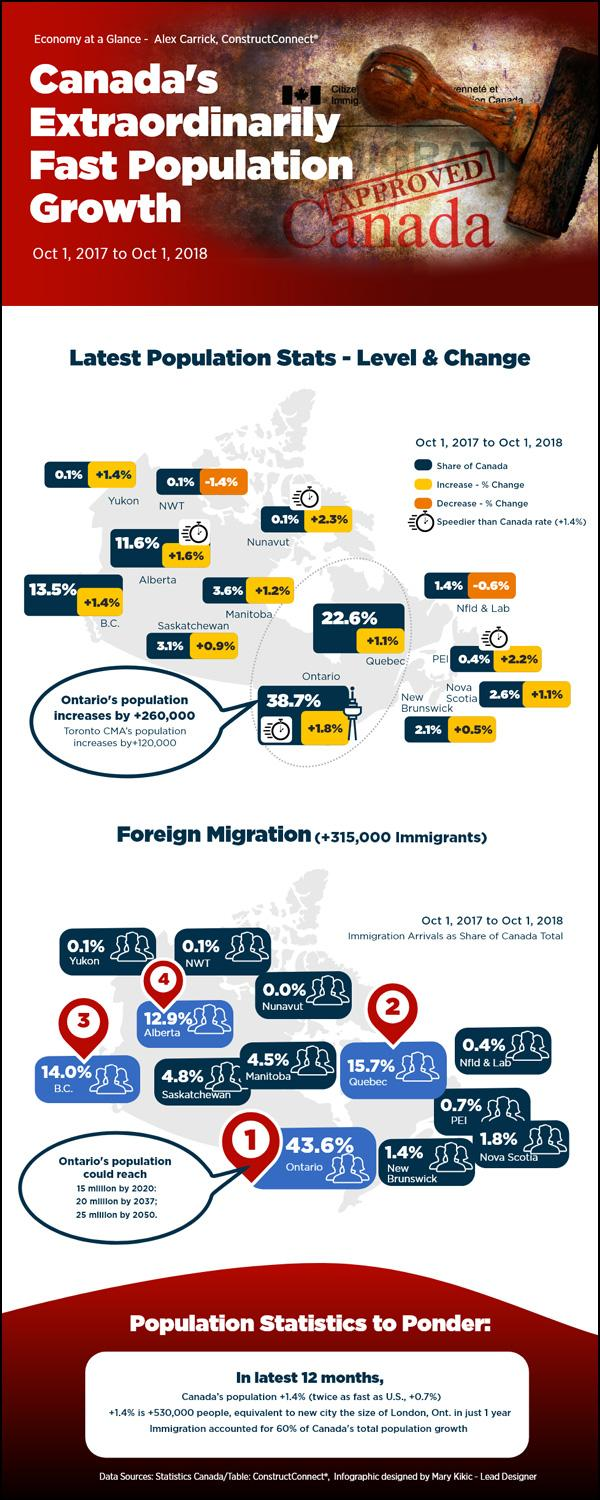List a handful of essential elements in this visual. Prince Edward Island has the second-highest increase in population growth among all places in Canada. Quebec is the second-largest contributor to the total population of Canada. In Quebec, approximately 22.6% of the Canadian population resides. According to data, approximately 43.6% of the population in Ontario is made up of foreign individuals. Nunavut has the highest population growth rate increase in Canada. 